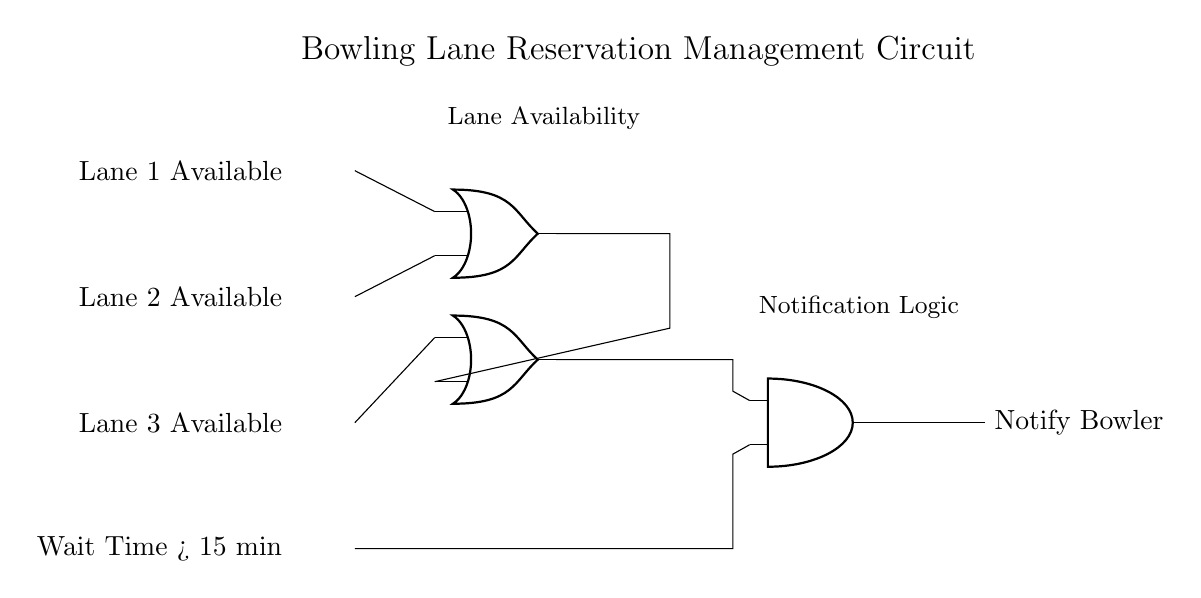What are the input signals of the circuit? The input signals are Lane 1 Available, Lane 2 Available, Lane 3 Available, and Wait Time > 15 min. These are indicated on the left side of the circuit diagram.
Answer: Lane 1 Available, Lane 2 Available, Lane 3 Available, Wait Time > 15 min How many OR gates are used in the circuit? There are two OR gates in the circuit. One OR gate is used for the lane availability signals, and the other is for the wait time signal.
Answer: 2 What is the logical operation performed by the AND gate? The AND gate combines the output from the OR gate (which handles lane availability) and the wait time signal. It results in a notification being sent only when the conditions permit. This is a basic characteristic of an AND gate which requires all inputs to be true for the output to be true.
Answer: AND If Lane 1 and Lane 2 are available and Wait Time is 20 minutes, what will the output be? For the output to be "Notify Bowler," the OR gate handling Lane 1 and Lane 2 signals will output true. Since the Wait Time is greater than 15 minutes, the AND gate will receive two true inputs. Therefore, the output will be "Notify Bowler."
Answer: Notify Bowler What does the output of the circuit indicate? The output indicates whether to notify the bowler based on the lane availability and wait time. If conditions are met, it triggers a notification.
Answer: Notify Bowler 